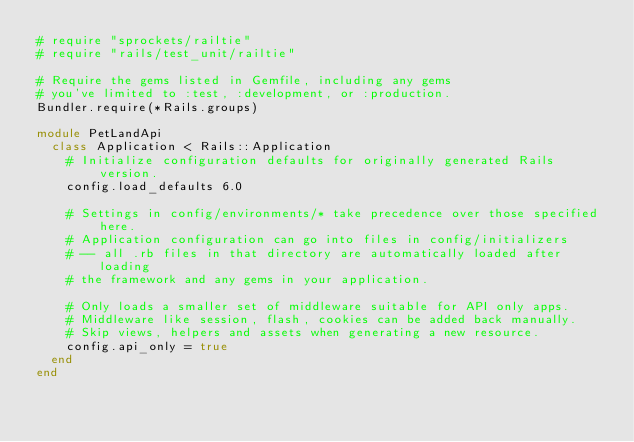Convert code to text. <code><loc_0><loc_0><loc_500><loc_500><_Ruby_># require "sprockets/railtie"
# require "rails/test_unit/railtie"

# Require the gems listed in Gemfile, including any gems
# you've limited to :test, :development, or :production.
Bundler.require(*Rails.groups)

module PetLandApi
  class Application < Rails::Application
    # Initialize configuration defaults for originally generated Rails version.
    config.load_defaults 6.0

    # Settings in config/environments/* take precedence over those specified here.
    # Application configuration can go into files in config/initializers
    # -- all .rb files in that directory are automatically loaded after loading
    # the framework and any gems in your application.

    # Only loads a smaller set of middleware suitable for API only apps.
    # Middleware like session, flash, cookies can be added back manually.
    # Skip views, helpers and assets when generating a new resource.
    config.api_only = true
  end
end
</code> 